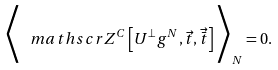<formula> <loc_0><loc_0><loc_500><loc_500>\Big < { { \ m a t h s c r { Z } } ^ { C } } \left [ { U } ^ { \perp } g ^ { N } , \vec { t } , \vec { \bar { t } } \right ] \Big > _ { N } = 0 .</formula> 